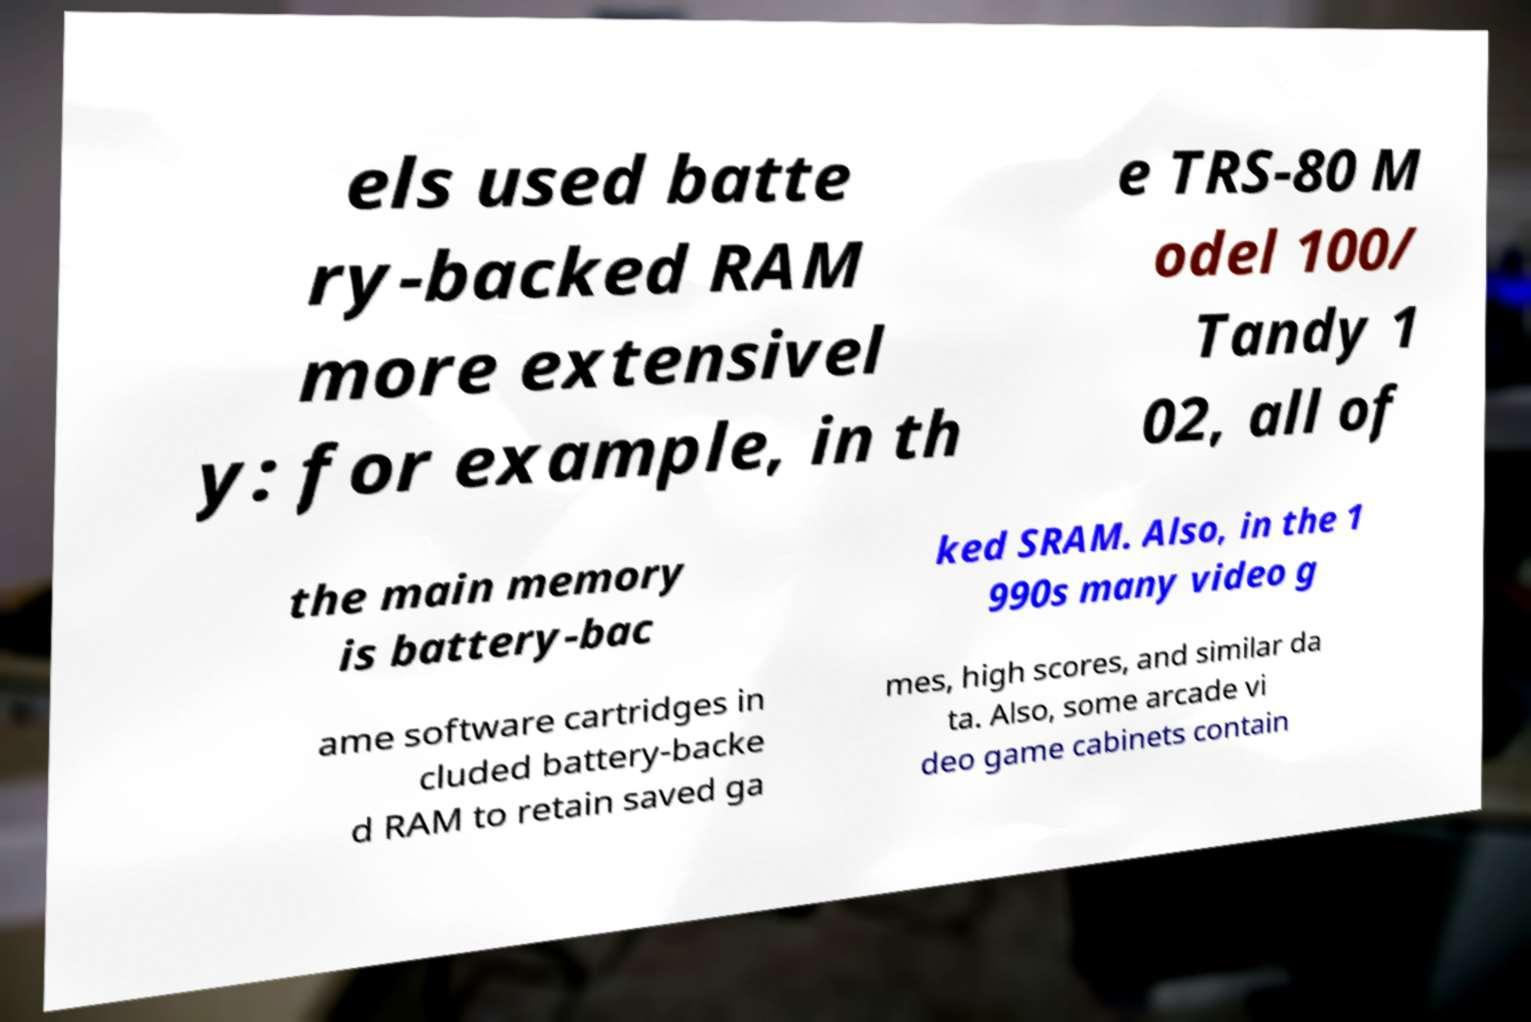For documentation purposes, I need the text within this image transcribed. Could you provide that? els used batte ry-backed RAM more extensivel y: for example, in th e TRS-80 M odel 100/ Tandy 1 02, all of the main memory is battery-bac ked SRAM. Also, in the 1 990s many video g ame software cartridges in cluded battery-backe d RAM to retain saved ga mes, high scores, and similar da ta. Also, some arcade vi deo game cabinets contain 